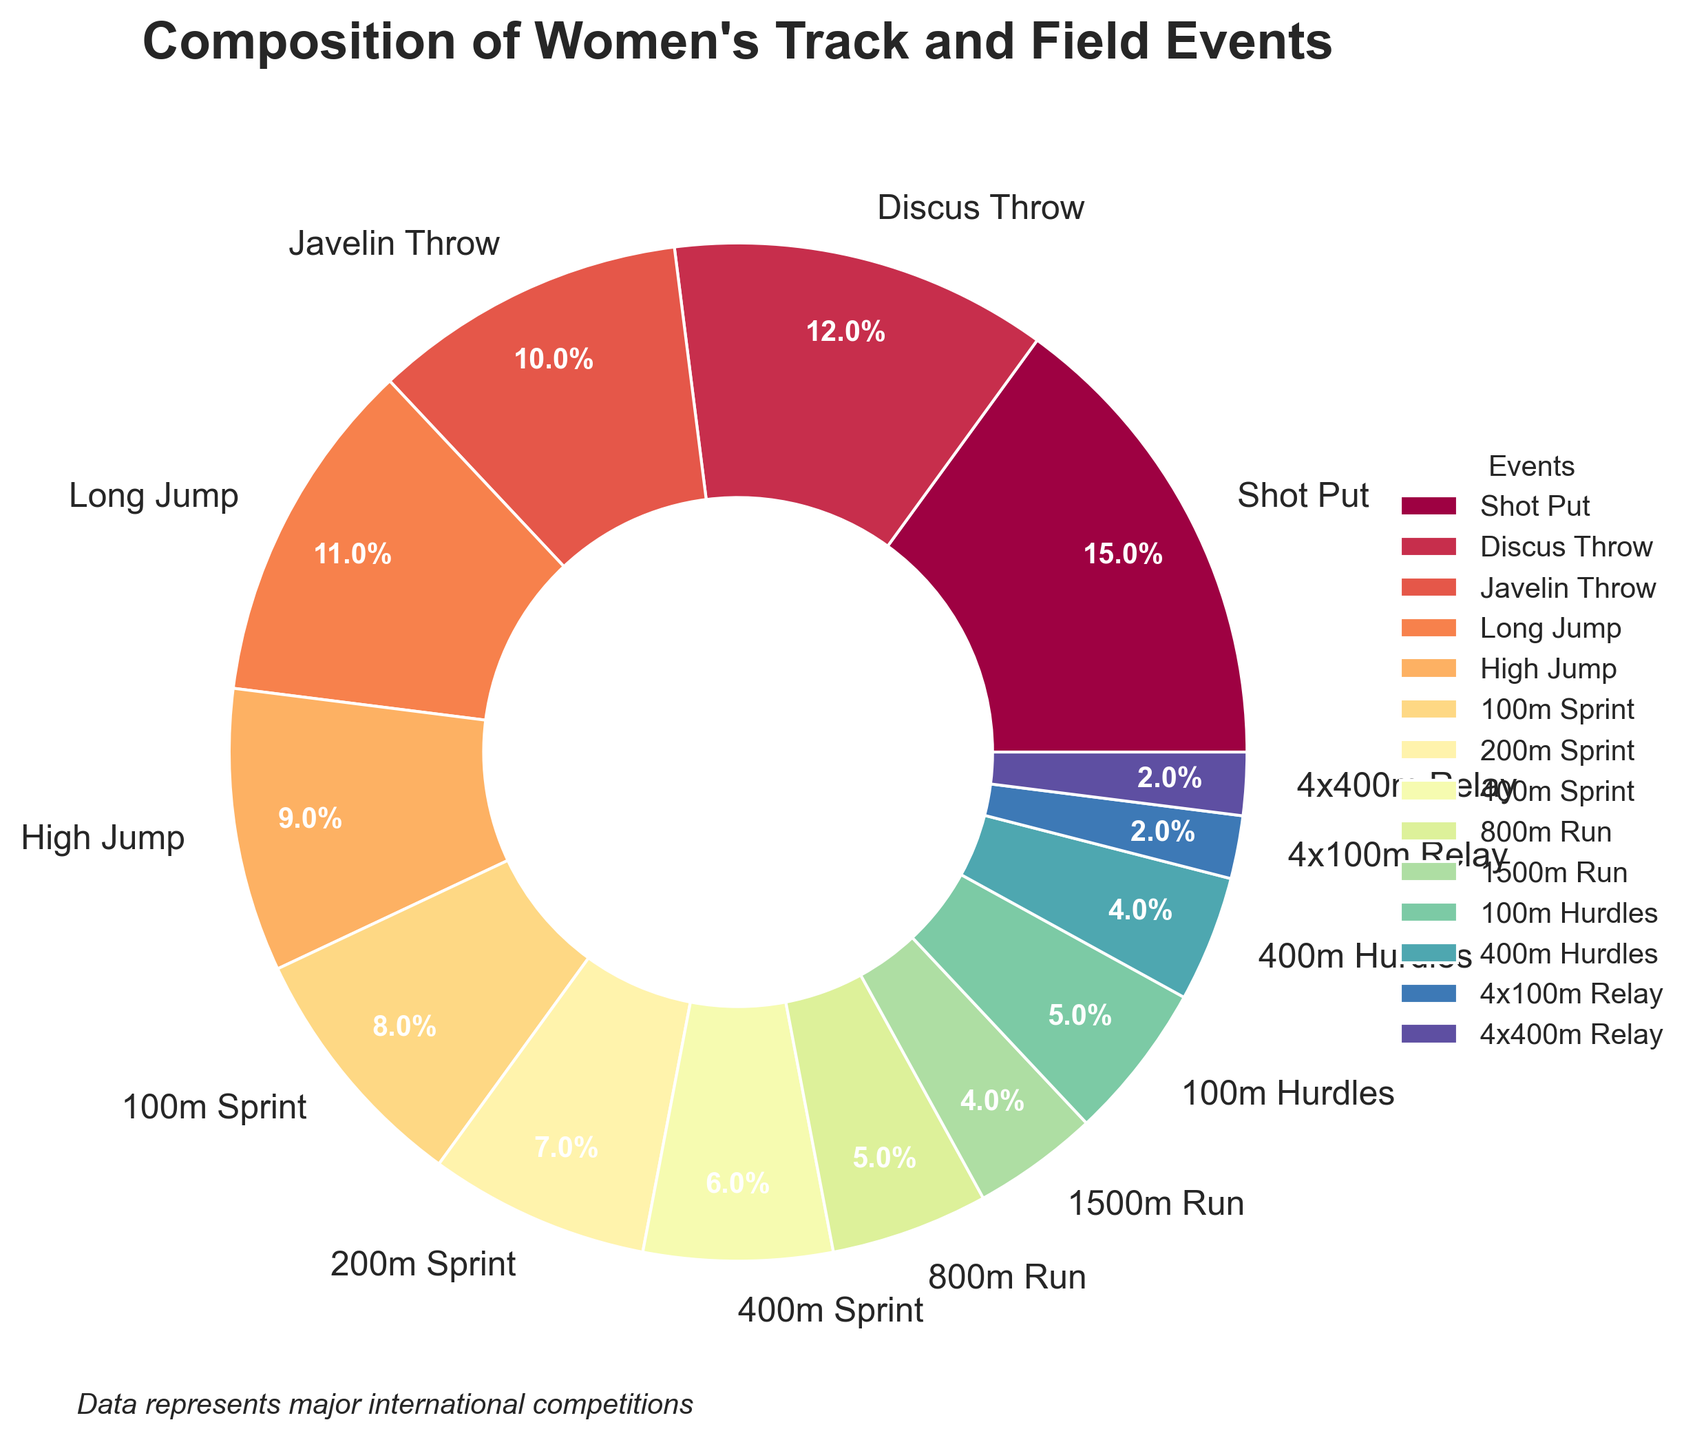Which event has the highest percentage in the pie chart? By looking at the size of the slices in the pie chart, the largest slice corresponds to the Shot Put event at 15%.
Answer: Shot Put Which three events combined make up the largest share of the composition? Sum the percentages of the three highest categories: Shot Put (15%), Discus Throw (12%), and Javelin Throw (10%). The total is 15 + 12 + 10 = 37%.
Answer: Shot Put, Discus Throw, Javelin Throw How much larger is the percentage of Shot Put compared to 200m Sprint? Shot Put has 15% and 200m Sprint has 7%. The difference is 15 - 7 = 8%.
Answer: 8% Does the combined percentage of the 100m Sprint and 400m Hurdles equal the percentage of the Discus Throw? 100m Sprint is 8% and 400m Hurdles is 4%. Sum them: 8 + 4 = 12%. The percentage of the Discus Throw is also 12%.
Answer: Yes Which event has a higher percentage, Long Jump or 800m Run? The percentage for Long Jump is 11%, and for 800m Run, it is 5%. So, Long Jump has a higher percentage.
Answer: Long Jump Do the combined percentages of the two relay events equal any other event’s percentage? The 4x100m Relay and 4x400m Relay are both 2% each. Combined, they make 2 + 2 = 4%. The percentage for the 1500m Run is also 4%.
Answer: Yes By what percentage does the High Jump event exceed the 4x100m Relay event? High Jump has 9% and 4x100m Relay has 2%. The difference is 9 - 2 = 7%.
Answer: 7% What is the sum of the percentages for all the sprint events (100m, 200m, 400m)? 100m Sprint is 8%, 200m Sprint is 7%, and 400m Sprint is 6%. Adding them together: 8 + 7 + 6 = 21%.
Answer: 21% What is the average percentage of the three throwing events (Shot Put, Discus Throw, Javelin Throw)? Shot Put is 15%, Discus Throw is 12%, and Javelin Throw is 10%. Sum them and divide by 3: (15 + 12 + 10) / 3 = 37 / 3 ≈ 12.33%.
Answer: 12.33% Which event has the smallest percentage and what is it? The smallest percentage found in the pie chart corresponds to both 4x100m Relay and 4x400m Relay, each at 2%.
Answer: 4x100m Relay and 4x400m Relay 